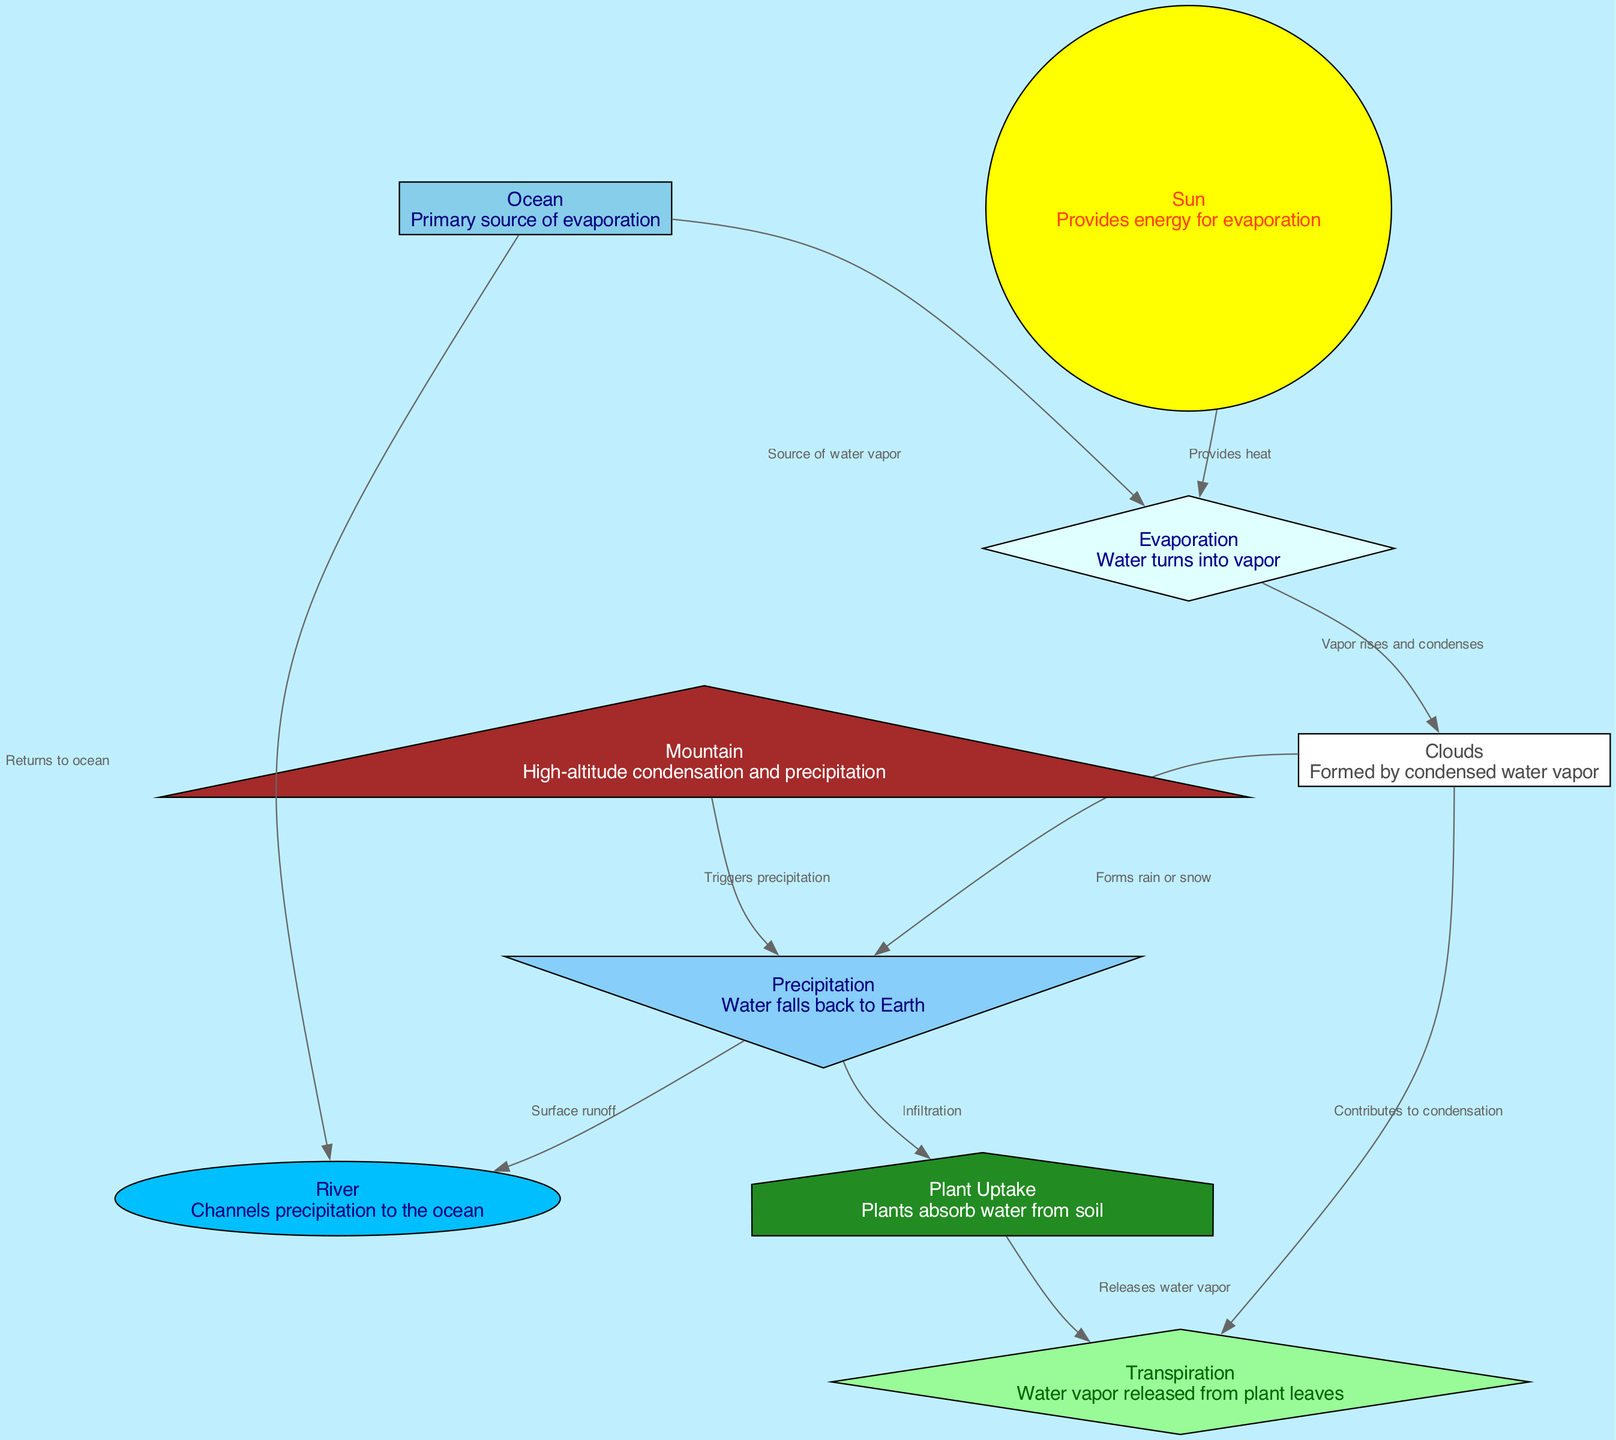What is the primary source of evaporation? The node labeled "Ocean" is identified as the primary source of evaporation in the diagram. This is directly stated in the description of the node.
Answer: Ocean How many total nodes are in the diagram? By counting all the unique entities represented in the diagram, which include Ocean, Sun, Evaporation, Clouds, Mountain, Precipitation, River, Plant Uptake, and Transpiration, we find a total of 9 nodes.
Answer: 9 What process follows evaporation in the water cycle? After evaporation, the diagram indicates that vapor rises and condenses into Clouds. This relationship is connected through a directed edge labeled "Vapor rises and condenses."
Answer: Clouds What does precipitation trigger according to the diagram? The diagram shows that Precipitation triggers a flow towards the River, as indicated by the labeled edge "Surface runoff." It also leads to Plant Uptake.
Answer: River, Plant Uptake What role does transpiration play in the water cycle? Transpiration is depicted in the diagram as releasing water vapor from plant leaves, which is indicated by the edge directed towards Clouds labeled "Contributes to condensation." This shows that transpiration contributes to the formation of clouds.
Answer: Releases water vapor How does the sun influence the water cycle? The Sun provides heat to the evaporation process, which is indicated by the edge connecting Sun to Evaporation labeled "Provides heat." This implies that without the sun's energy, evaporation would not occur efficiently.
Answer: Provides heat 